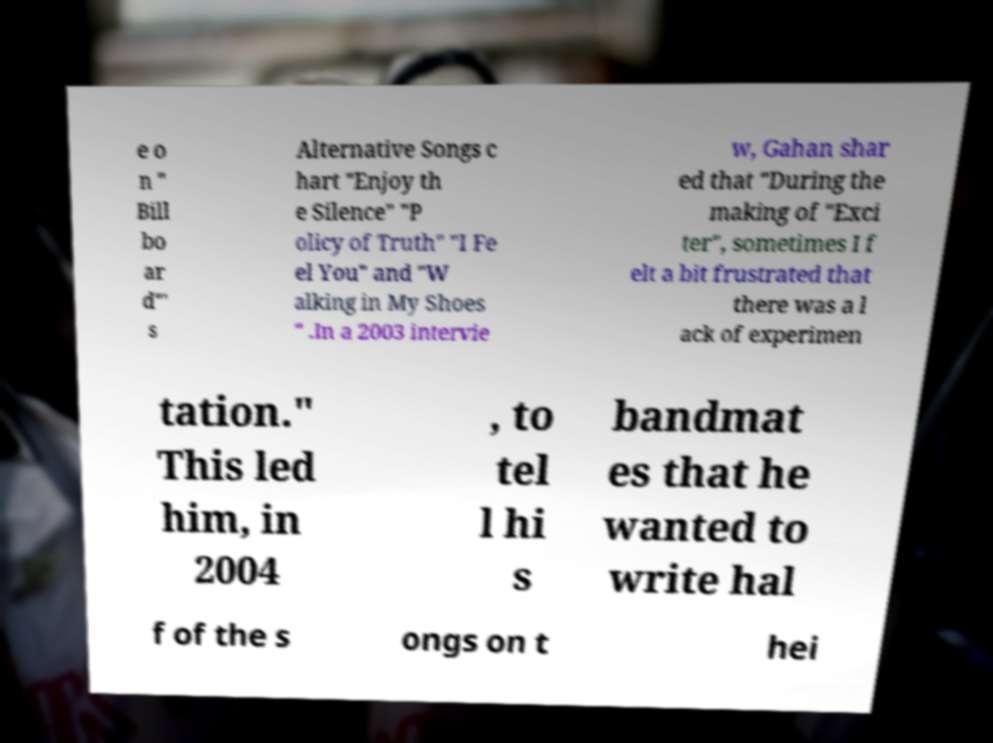Could you extract and type out the text from this image? e o n " Bill bo ar d"' s Alternative Songs c hart "Enjoy th e Silence" "P olicy of Truth" "I Fe el You" and "W alking in My Shoes " .In a 2003 intervie w, Gahan shar ed that "During the making of "Exci ter", sometimes I f elt a bit frustrated that there was a l ack of experimen tation." This led him, in 2004 , to tel l hi s bandmat es that he wanted to write hal f of the s ongs on t hei 